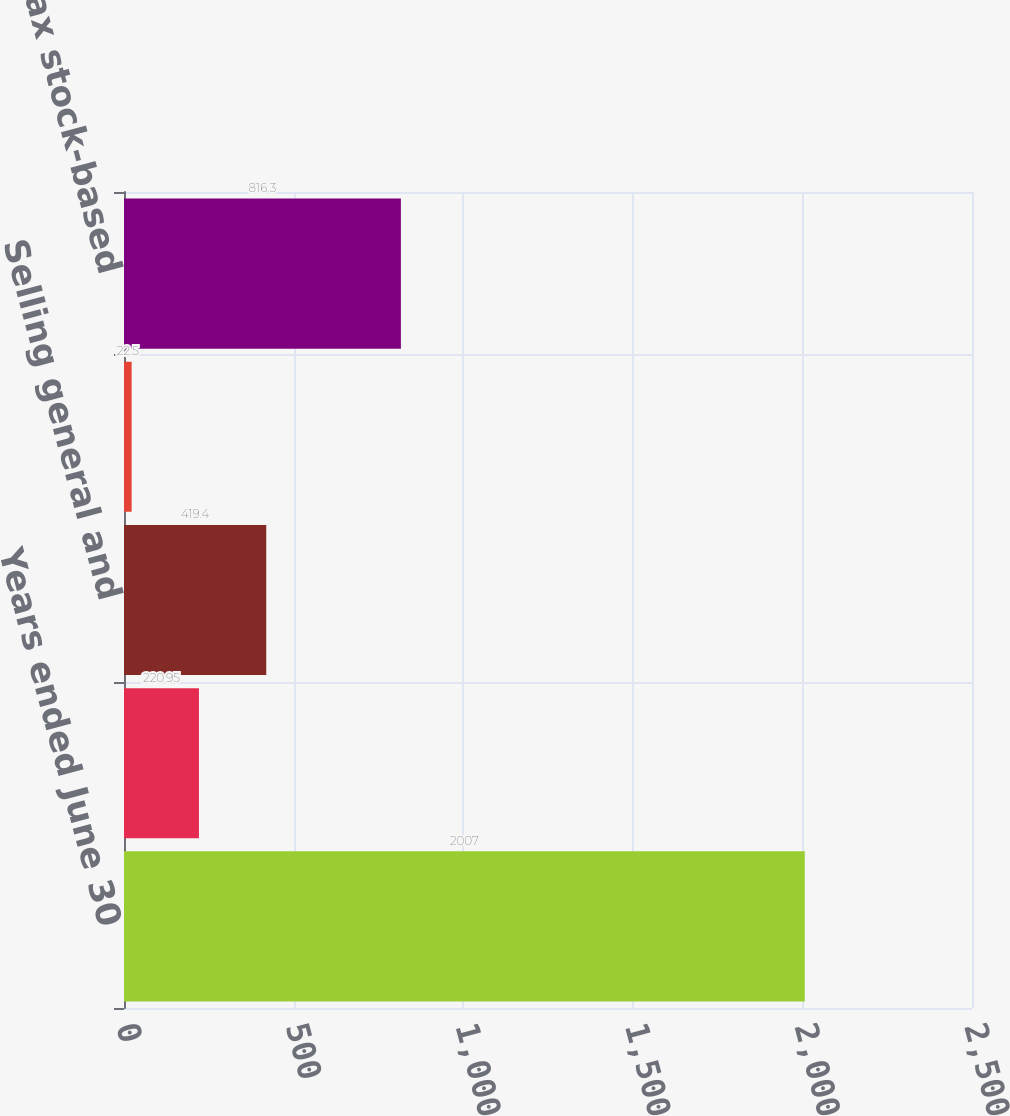Convert chart. <chart><loc_0><loc_0><loc_500><loc_500><bar_chart><fcel>Years ended June 30<fcel>Operating expenses<fcel>Selling general and<fcel>System development and<fcel>Total pretax stock-based<nl><fcel>2007<fcel>220.95<fcel>419.4<fcel>22.5<fcel>816.3<nl></chart> 